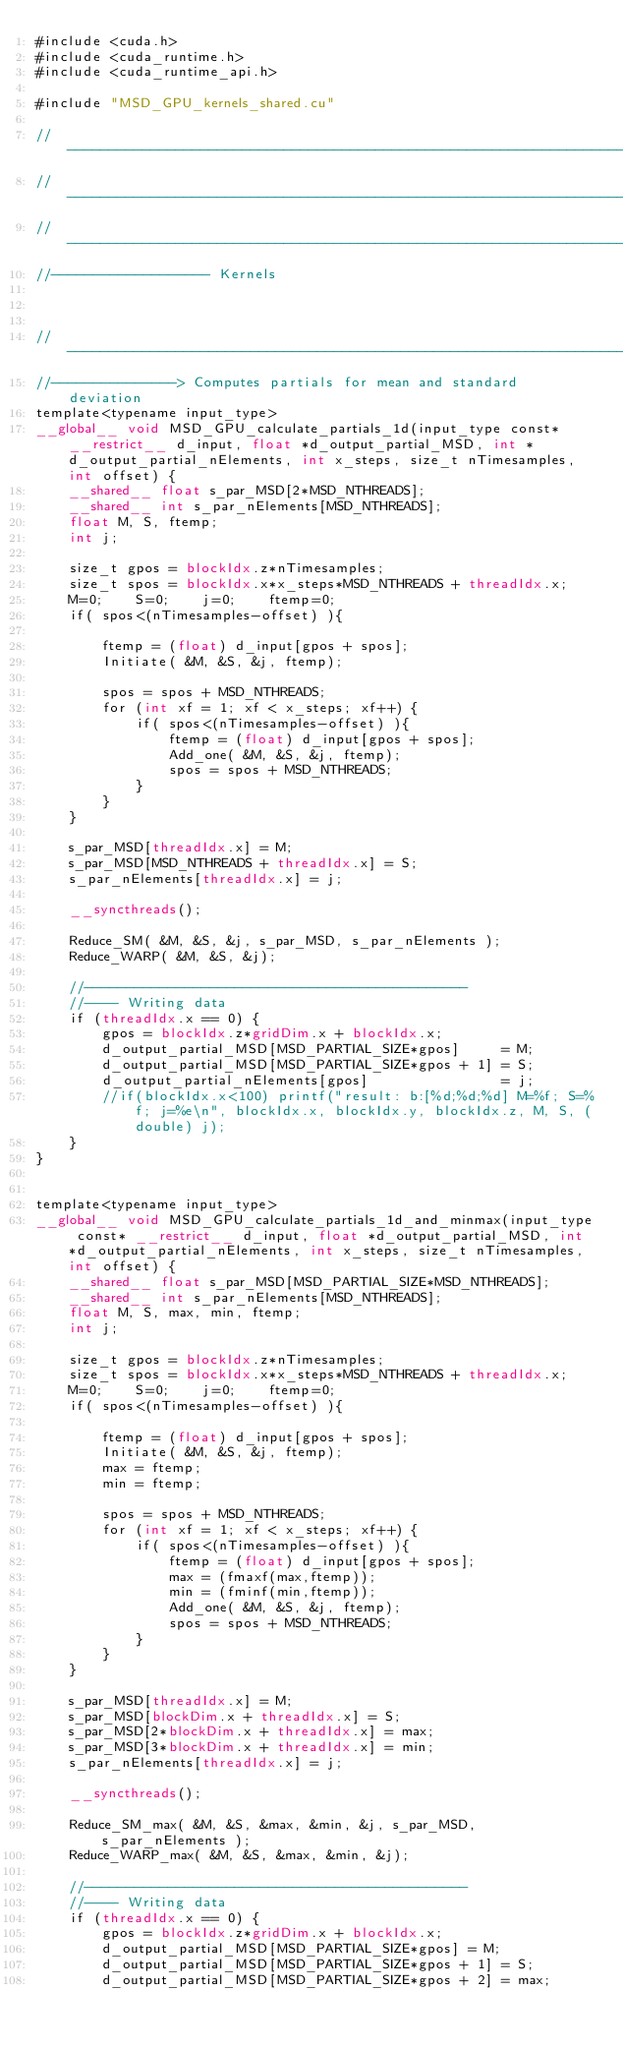<code> <loc_0><loc_0><loc_500><loc_500><_Cuda_>#include <cuda.h>
#include <cuda_runtime.h>
#include <cuda_runtime_api.h>

#include "MSD_GPU_kernels_shared.cu"

//----------------------------------------------------------------------------------------
//----------------------------------------------------------------------------------------
//----------------------------------------------------------------------------------------
//------------------- Kernels



//-----------------------------------------------------------------------
//---------------> Computes partials for mean and standard deviation
template<typename input_type>
__global__ void MSD_GPU_calculate_partials_1d(input_type const* __restrict__ d_input, float *d_output_partial_MSD, int *d_output_partial_nElements, int x_steps, size_t nTimesamples, int offset) {
	__shared__ float s_par_MSD[2*MSD_NTHREADS];
	__shared__ int s_par_nElements[MSD_NTHREADS];
	float M, S, ftemp;
	int j;
	
	size_t gpos = blockIdx.z*nTimesamples;
	size_t spos = blockIdx.x*x_steps*MSD_NTHREADS + threadIdx.x;
	M=0;	S=0;	j=0;	ftemp=0;
	if( spos<(nTimesamples-offset) ){
		
		ftemp = (float) d_input[gpos + spos];
		Initiate( &M, &S, &j, ftemp);
		
		spos = spos + MSD_NTHREADS;
		for (int xf = 1; xf < x_steps; xf++) {
			if( spos<(nTimesamples-offset) ){
				ftemp = (float) d_input[gpos + spos];
				Add_one( &M, &S, &j, ftemp);
				spos = spos + MSD_NTHREADS;
			}
		}
	}
	
	s_par_MSD[threadIdx.x] = M;
	s_par_MSD[MSD_NTHREADS + threadIdx.x] = S;
	s_par_nElements[threadIdx.x] = j;
	
	__syncthreads();
	
	Reduce_SM( &M, &S, &j, s_par_MSD, s_par_nElements );
	Reduce_WARP( &M, &S, &j);
	
	//----------------------------------------------
	//---- Writing data
	if (threadIdx.x == 0) {
		gpos = blockIdx.z*gridDim.x + blockIdx.x;
		d_output_partial_MSD[MSD_PARTIAL_SIZE*gpos]     = M;
		d_output_partial_MSD[MSD_PARTIAL_SIZE*gpos + 1] = S;
		d_output_partial_nElements[gpos]                = j;
		//if(blockIdx.x<100) printf("result: b:[%d;%d;%d] M=%f; S=%f; j=%e\n", blockIdx.x, blockIdx.y, blockIdx.z, M, S, (double) j);
	}
}


template<typename input_type>
__global__ void MSD_GPU_calculate_partials_1d_and_minmax(input_type const* __restrict__ d_input, float *d_output_partial_MSD, int *d_output_partial_nElements, int x_steps, size_t nTimesamples, int offset) {
	__shared__ float s_par_MSD[MSD_PARTIAL_SIZE*MSD_NTHREADS];
	__shared__ int s_par_nElements[MSD_NTHREADS];
	float M, S, max, min, ftemp;
	int j;
	
	size_t gpos = blockIdx.z*nTimesamples;
	size_t spos = blockIdx.x*x_steps*MSD_NTHREADS + threadIdx.x;
	M=0;	S=0;	j=0;	ftemp=0;
	if( spos<(nTimesamples-offset) ){
		
		ftemp = (float) d_input[gpos + spos];
		Initiate( &M, &S, &j, ftemp);
		max = ftemp;
		min = ftemp;
		
		spos = spos + MSD_NTHREADS;
		for (int xf = 1; xf < x_steps; xf++) {
			if( spos<(nTimesamples-offset) ){
				ftemp = (float) d_input[gpos + spos];
				max = (fmaxf(max,ftemp));
				min = (fminf(min,ftemp));
				Add_one( &M, &S, &j, ftemp);
				spos = spos + MSD_NTHREADS;
			}
		}
	}
	
	s_par_MSD[threadIdx.x] = M;
	s_par_MSD[blockDim.x + threadIdx.x] = S;
	s_par_MSD[2*blockDim.x + threadIdx.x] = max;
	s_par_MSD[3*blockDim.x + threadIdx.x] = min;
	s_par_nElements[threadIdx.x] = j;
	
	__syncthreads();
	
	Reduce_SM_max( &M, &S, &max, &min, &j, s_par_MSD, s_par_nElements );
	Reduce_WARP_max( &M, &S, &max, &min, &j);
	
	//----------------------------------------------
	//---- Writing data
	if (threadIdx.x == 0) {
		gpos = blockIdx.z*gridDim.x + blockIdx.x;
		d_output_partial_MSD[MSD_PARTIAL_SIZE*gpos] = M;
		d_output_partial_MSD[MSD_PARTIAL_SIZE*gpos + 1] = S;
		d_output_partial_MSD[MSD_PARTIAL_SIZE*gpos + 2] = max;</code> 